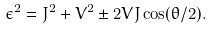<formula> <loc_0><loc_0><loc_500><loc_500>\epsilon ^ { 2 } = J ^ { 2 } + V ^ { 2 } \pm 2 V J \cos ( \theta / 2 ) .</formula> 